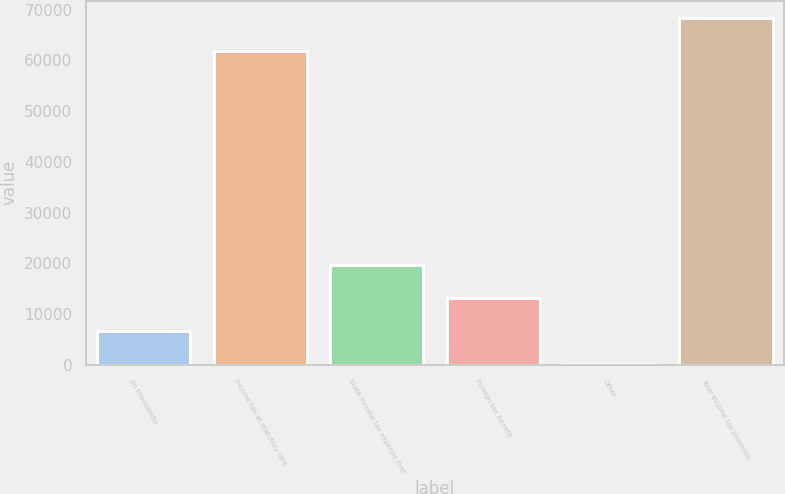Convert chart to OTSL. <chart><loc_0><loc_0><loc_500><loc_500><bar_chart><fcel>(in thousands)<fcel>Income tax at statutory rate<fcel>State income tax expense (net<fcel>Foreign tax benefit<fcel>Other<fcel>Total income tax provision<nl><fcel>6720<fcel>61825<fcel>19740<fcel>13230<fcel>210<fcel>68335<nl></chart> 